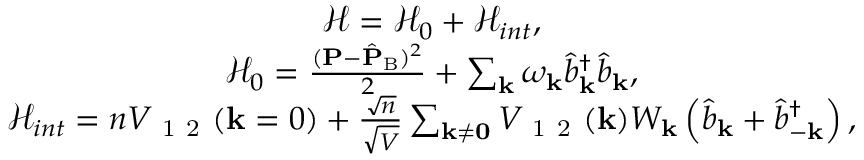Convert formula to latex. <formula><loc_0><loc_0><loc_500><loc_500>\begin{array} { r } { \begin{array} { c } { \mathcal { H } = \mathcal { H } _ { 0 } + \mathcal { H } _ { i n t } , } \\ { \mathcal { H } _ { 0 } = \frac { ( { P } - \hat { P } _ { B } ) ^ { 2 } } { 2 } + \sum _ { k } \omega _ { k } \hat { b } _ { k } ^ { \dagger } \hat { b } _ { k } , } \\ { \mathcal { H } _ { i n t } = n V _ { 1 2 } ( k = 0 ) + \frac { \sqrt { n } } { \sqrt { V } } \sum _ { k \neq 0 } V _ { 1 2 } ( k ) W _ { k } \left ( \hat { b } _ { k } + \hat { b } _ { - k } ^ { \dagger } \right ) , } \end{array} } \end{array}</formula> 